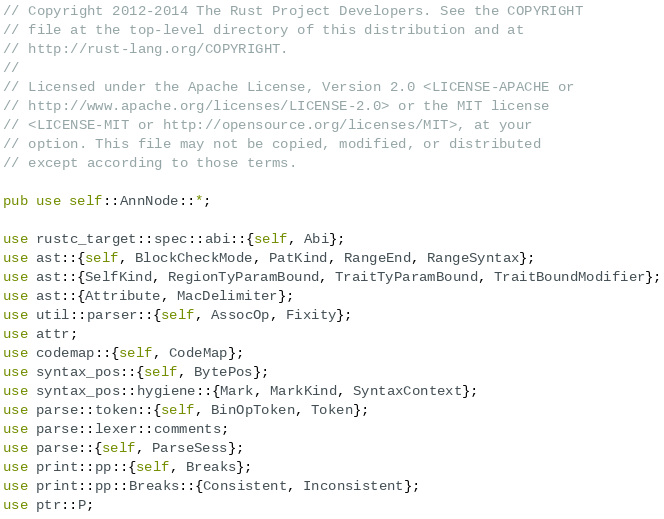Convert code to text. <code><loc_0><loc_0><loc_500><loc_500><_Rust_>// Copyright 2012-2014 The Rust Project Developers. See the COPYRIGHT
// file at the top-level directory of this distribution and at
// http://rust-lang.org/COPYRIGHT.
//
// Licensed under the Apache License, Version 2.0 <LICENSE-APACHE or
// http://www.apache.org/licenses/LICENSE-2.0> or the MIT license
// <LICENSE-MIT or http://opensource.org/licenses/MIT>, at your
// option. This file may not be copied, modified, or distributed
// except according to those terms.

pub use self::AnnNode::*;

use rustc_target::spec::abi::{self, Abi};
use ast::{self, BlockCheckMode, PatKind, RangeEnd, RangeSyntax};
use ast::{SelfKind, RegionTyParamBound, TraitTyParamBound, TraitBoundModifier};
use ast::{Attribute, MacDelimiter};
use util::parser::{self, AssocOp, Fixity};
use attr;
use codemap::{self, CodeMap};
use syntax_pos::{self, BytePos};
use syntax_pos::hygiene::{Mark, MarkKind, SyntaxContext};
use parse::token::{self, BinOpToken, Token};
use parse::lexer::comments;
use parse::{self, ParseSess};
use print::pp::{self, Breaks};
use print::pp::Breaks::{Consistent, Inconsistent};
use ptr::P;</code> 